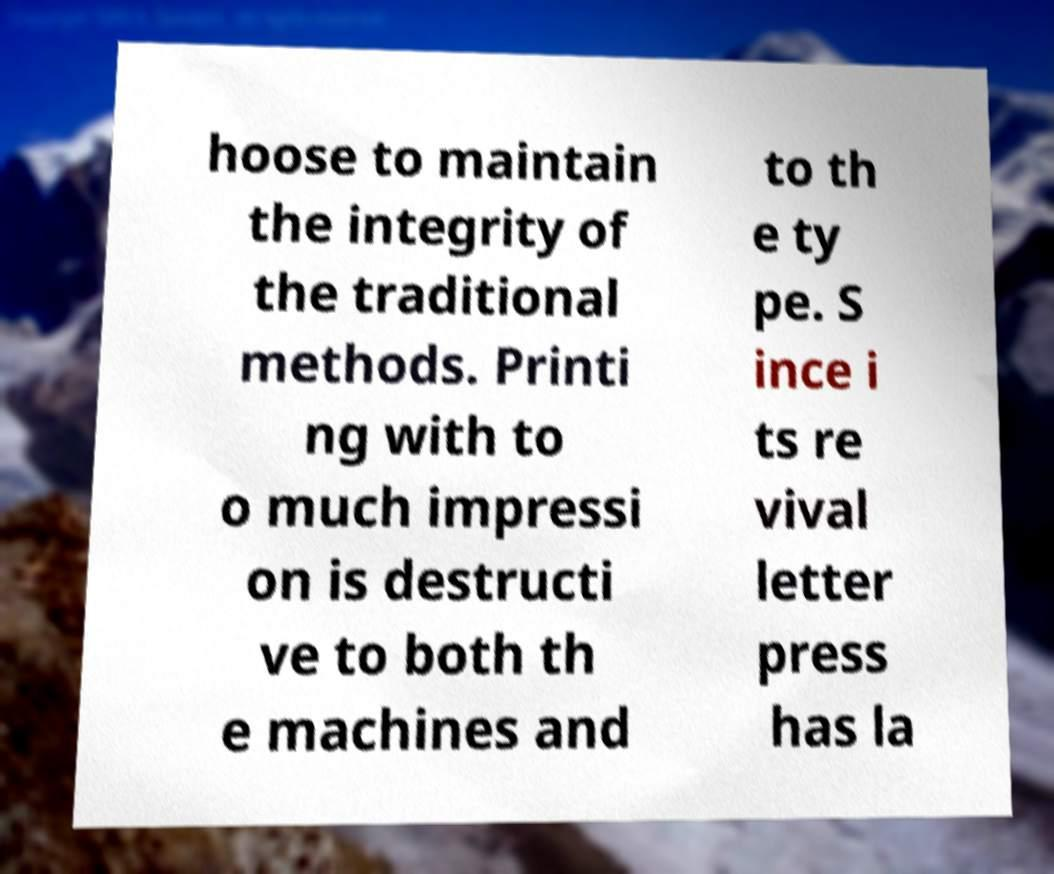There's text embedded in this image that I need extracted. Can you transcribe it verbatim? hoose to maintain the integrity of the traditional methods. Printi ng with to o much impressi on is destructi ve to both th e machines and to th e ty pe. S ince i ts re vival letter press has la 